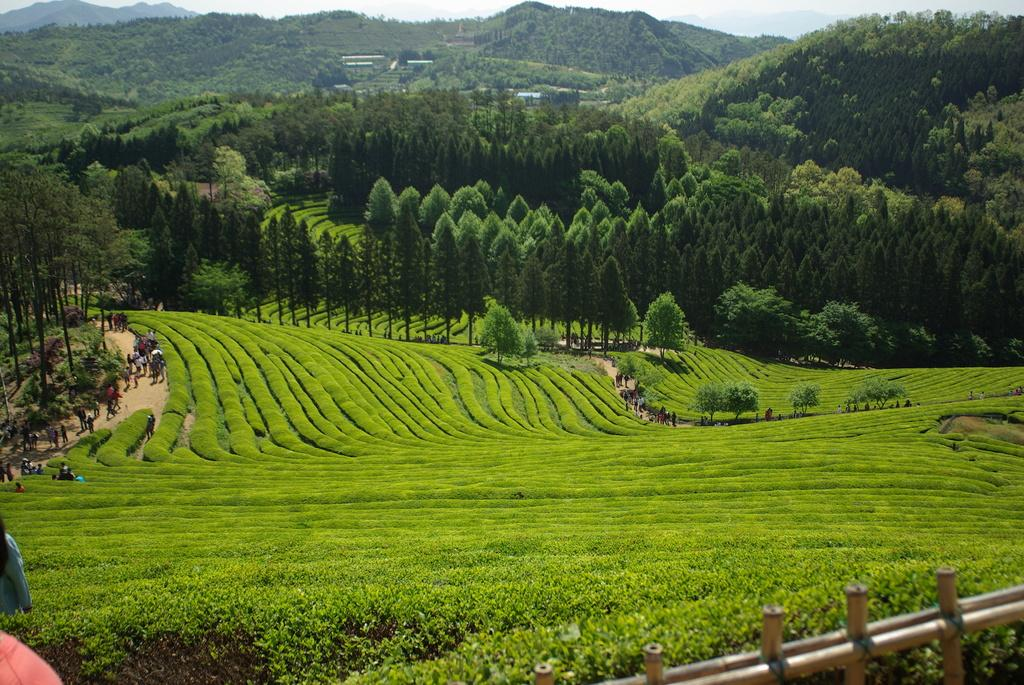What are the people in the image doing? The people in the image are walking on the road. What type of vegetation can be seen in the image? There are trees visible in the image. What type of agricultural land can be seen in the image? There are coffee fields in the image. What can be seen in the distance in the image? There are mountains in the background of the image. Where is the faucet located in the image? There is no faucet present in the image. How many cats can be seen in the image? There are no cats present in the image. 